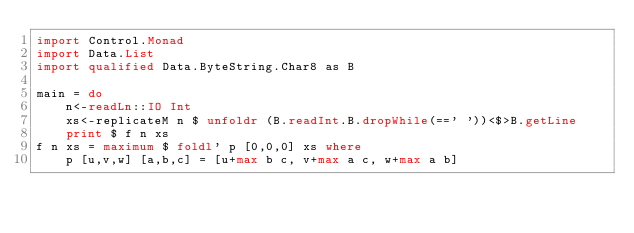<code> <loc_0><loc_0><loc_500><loc_500><_Haskell_>import Control.Monad
import Data.List
import qualified Data.ByteString.Char8 as B

main = do
    n<-readLn::IO Int
    xs<-replicateM n $ unfoldr (B.readInt.B.dropWhile(==' '))<$>B.getLine
    print $ f n xs
f n xs = maximum $ foldl' p [0,0,0] xs where
    p [u,v,w] [a,b,c] = [u+max b c, v+max a c, w+max a b]
</code> 